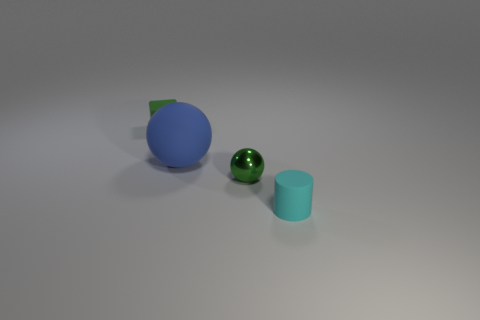Add 2 small blue cylinders. How many objects exist? 6 Subtract all cylinders. How many objects are left? 3 Subtract all blue matte spheres. Subtract all large balls. How many objects are left? 2 Add 2 cylinders. How many cylinders are left? 3 Add 2 small matte blocks. How many small matte blocks exist? 3 Subtract 0 gray cubes. How many objects are left? 4 